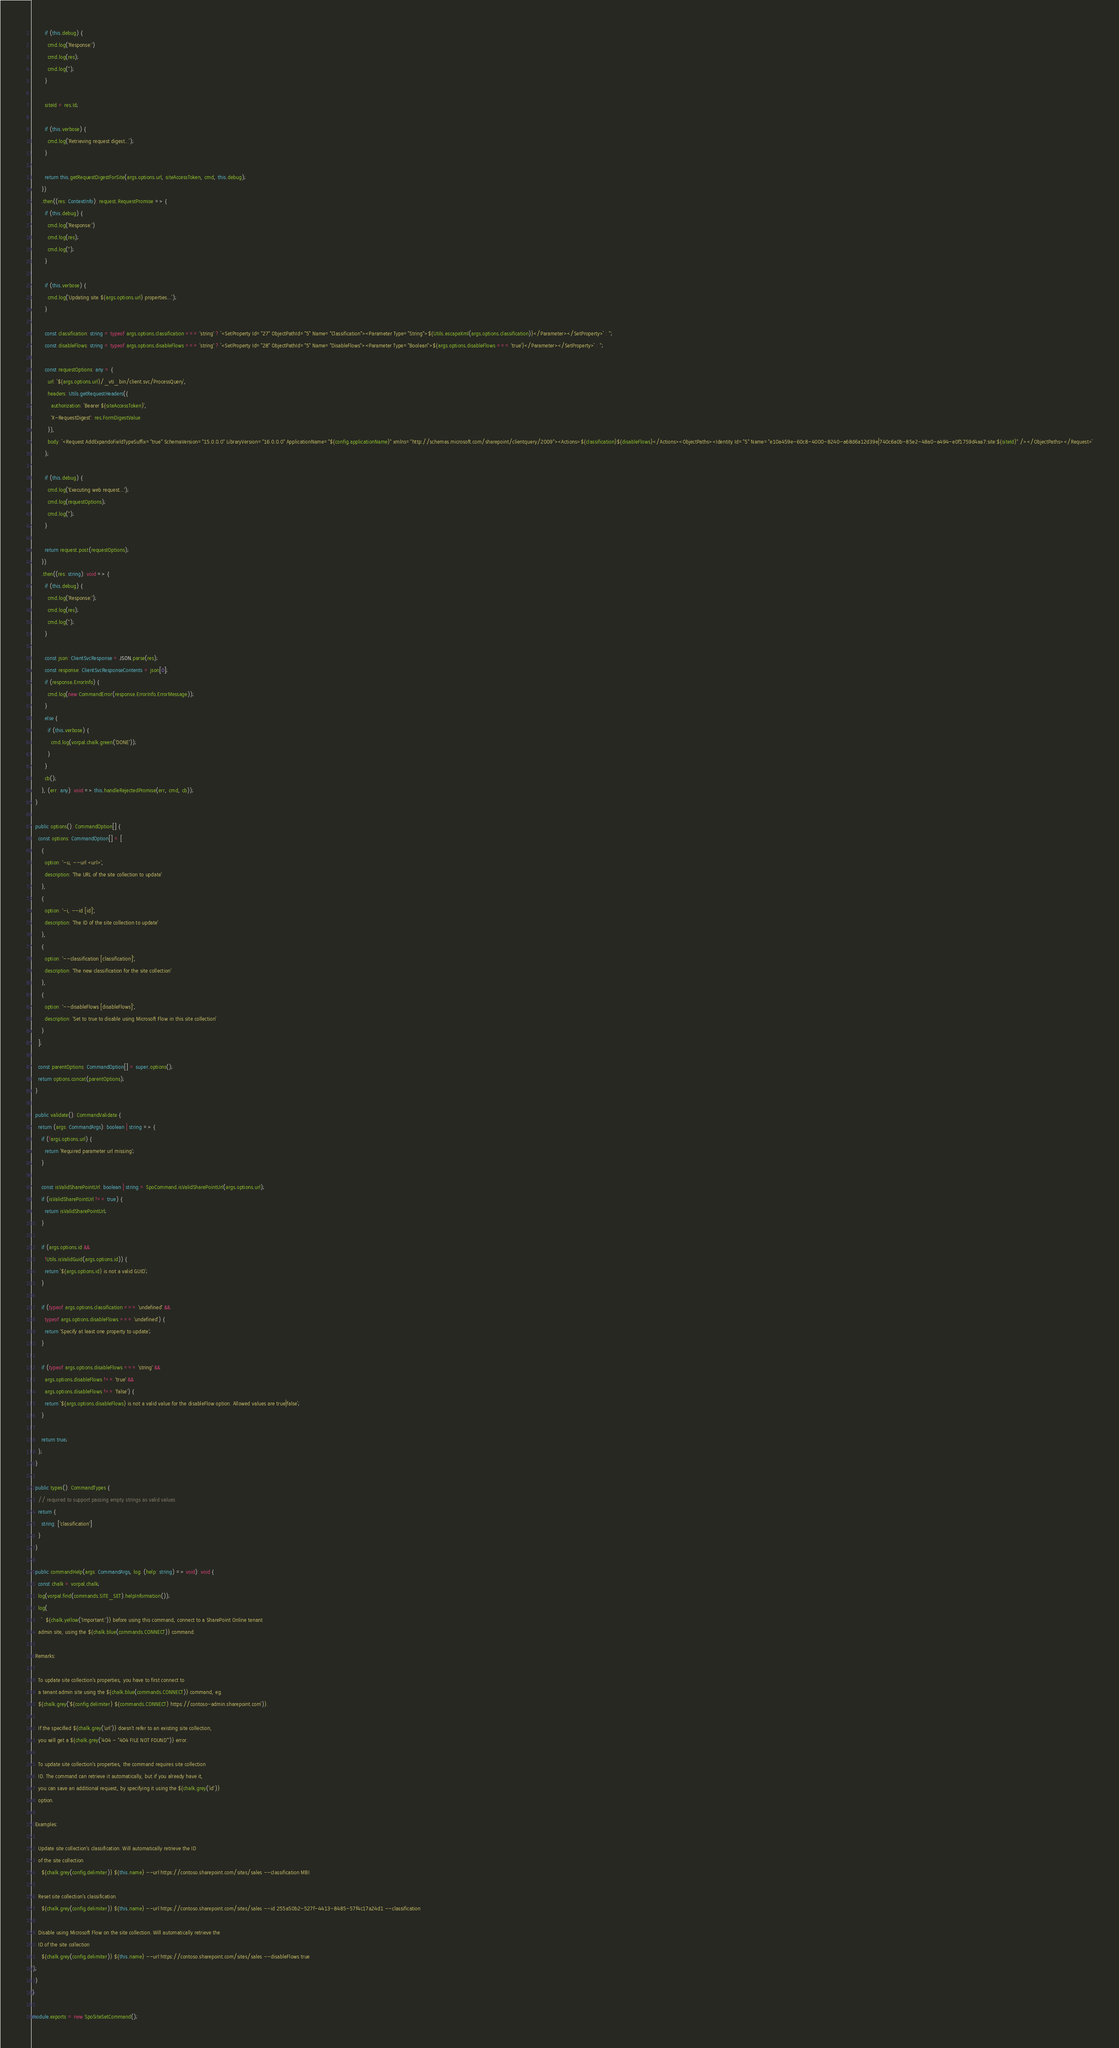<code> <loc_0><loc_0><loc_500><loc_500><_TypeScript_>        if (this.debug) {
          cmd.log('Response:')
          cmd.log(res);
          cmd.log('');
        }

        siteId = res.Id;

        if (this.verbose) {
          cmd.log(`Retrieving request digest...`);
        }

        return this.getRequestDigestForSite(args.options.url, siteAccessToken, cmd, this.debug);
      })
      .then((res: ContextInfo): request.RequestPromise => {
        if (this.debug) {
          cmd.log('Response:')
          cmd.log(res);
          cmd.log('');
        }

        if (this.verbose) {
          cmd.log(`Updating site ${args.options.url} properties...`);
        }

        const classification: string = typeof args.options.classification === 'string' ? `<SetProperty Id="27" ObjectPathId="5" Name="Classification"><Parameter Type="String">${Utils.escapeXml(args.options.classification)}</Parameter></SetProperty>` : '';
        const disableFlows: string = typeof args.options.disableFlows === 'string' ? `<SetProperty Id="28" ObjectPathId="5" Name="DisableFlows"><Parameter Type="Boolean">${args.options.disableFlows === 'true'}</Parameter></SetProperty>` : '';

        const requestOptions: any = {
          url: `${args.options.url}/_vti_bin/client.svc/ProcessQuery`,
          headers: Utils.getRequestHeaders({
            authorization: `Bearer ${siteAccessToken}`,
            'X-RequestDigest': res.FormDigestValue
          }),
          body: `<Request AddExpandoFieldTypeSuffix="true" SchemaVersion="15.0.0.0" LibraryVersion="16.0.0.0" ApplicationName="${config.applicationName}" xmlns="http://schemas.microsoft.com/sharepoint/clientquery/2009"><Actions>${classification}${disableFlows}</Actions><ObjectPaths><Identity Id="5" Name="e10a459e-60c8-4000-8240-a68d6a12d39e|740c6a0b-85e2-48a0-a494-e0f1759d4aa7:site:${siteId}" /></ObjectPaths></Request>`
        };

        if (this.debug) {
          cmd.log('Executing web request...');
          cmd.log(requestOptions);
          cmd.log('');
        }

        return request.post(requestOptions);
      })
      .then((res: string): void => {
        if (this.debug) {
          cmd.log('Response:');
          cmd.log(res);
          cmd.log('');
        }

        const json: ClientSvcResponse = JSON.parse(res);
        const response: ClientSvcResponseContents = json[0];
        if (response.ErrorInfo) {
          cmd.log(new CommandError(response.ErrorInfo.ErrorMessage));
        }
        else {
          if (this.verbose) {
            cmd.log(vorpal.chalk.green('DONE'));
          }
        }
        cb();
      }, (err: any): void => this.handleRejectedPromise(err, cmd, cb));
  }

  public options(): CommandOption[] {
    const options: CommandOption[] = [
      {
        option: '-u, --url <url>',
        description: 'The URL of the site collection to update'
      },
      {
        option: '-i, --id [id]',
        description: 'The ID of the site collection to update'
      },
      {
        option: '--classification [classification]',
        description: 'The new classification for the site collection'
      },
      {
        option: '--disableFlows [disableFlows]',
        description: 'Set to true to disable using Microsoft Flow in this site collection'
      }
    ];

    const parentOptions: CommandOption[] = super.options();
    return options.concat(parentOptions);
  }

  public validate(): CommandValidate {
    return (args: CommandArgs): boolean | string => {
      if (!args.options.url) {
        return 'Required parameter url missing';
      }

      const isValidSharePointUrl: boolean | string = SpoCommand.isValidSharePointUrl(args.options.url);
      if (isValidSharePointUrl !== true) {
        return isValidSharePointUrl;
      }

      if (args.options.id &&
        !Utils.isValidGuid(args.options.id)) {
        return `${args.options.id} is not a valid GUID`;
      }

      if (typeof args.options.classification === 'undefined' &&
        typeof args.options.disableFlows === 'undefined') {
        return 'Specify at least one property to update';
      }

      if (typeof args.options.disableFlows === 'string' &&
        args.options.disableFlows !== 'true' &&
        args.options.disableFlows !== 'false') {
        return `${args.options.disableFlows} is not a valid value for the disableFlow option. Allowed values are true|false`;
      }

      return true;
    };
  }

  public types(): CommandTypes {
    // required to support passing empty strings as valid values
    return {
      string: ['classification']
    }
  }

  public commandHelp(args: CommandArgs, log: (help: string) => void): void {
    const chalk = vorpal.chalk;
    log(vorpal.find(commands.SITE_SET).helpInformation());
    log(
      `  ${chalk.yellow('Important:')} before using this command, connect to a SharePoint Online tenant
    admin site, using the ${chalk.blue(commands.CONNECT)} command.
        
  Remarks:

    To update site collection's properties, you have to first connect to
    a tenant admin site using the ${chalk.blue(commands.CONNECT)} command, eg.
    ${chalk.grey(`${config.delimiter} ${commands.CONNECT} https://contoso-admin.sharepoint.com`)}.

    If the specified ${chalk.grey('url')} doesn't refer to an existing site collection,
    you will get a ${chalk.grey('404 - "404 FILE NOT FOUND"')} error.

    To update site collection's properties, the command requires site collection
    ID. The command can retrieve it automatically, but if you already have it,
    you can save an additional request, by specifying it using the ${chalk.grey('id')}
    option.

  Examples:
  
    Update site collection's classification. Will automatically retrieve the ID
    of the site collection
      ${chalk.grey(config.delimiter)} ${this.name} --url https://contoso.sharepoint.com/sites/sales --classification MBI

    Reset site collection's classification.
      ${chalk.grey(config.delimiter)} ${this.name} --url https://contoso.sharepoint.com/sites/sales --id 255a50b2-527f-4413-8485-57f4c17a24d1 --classification

    Disable using Microsoft Flow on the site collection. Will automatically retrieve the
    ID of the site collection
      ${chalk.grey(config.delimiter)} ${this.name} --url https://contoso.sharepoint.com/sites/sales --disableFlows true
`);
  }
}

module.exports = new SpoSiteSetCommand();</code> 